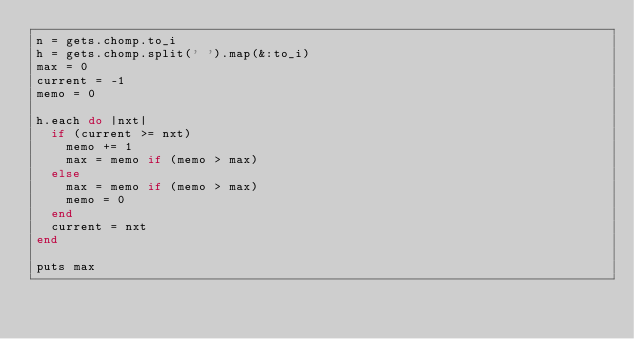Convert code to text. <code><loc_0><loc_0><loc_500><loc_500><_Ruby_>n = gets.chomp.to_i
h = gets.chomp.split(' ').map(&:to_i)
max = 0
current = -1
memo = 0

h.each do |nxt|
  if (current >= nxt)
    memo += 1
    max = memo if (memo > max)
  else
    max = memo if (memo > max)
    memo = 0
  end
  current = nxt
end

puts max</code> 